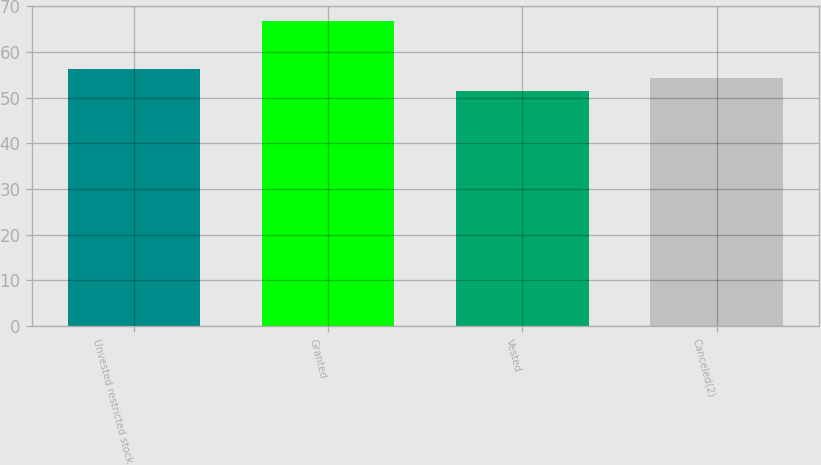<chart> <loc_0><loc_0><loc_500><loc_500><bar_chart><fcel>Unvested restricted stock<fcel>Granted<fcel>Vested<fcel>Canceled(2)<nl><fcel>56.22<fcel>66.68<fcel>51.33<fcel>54.21<nl></chart> 